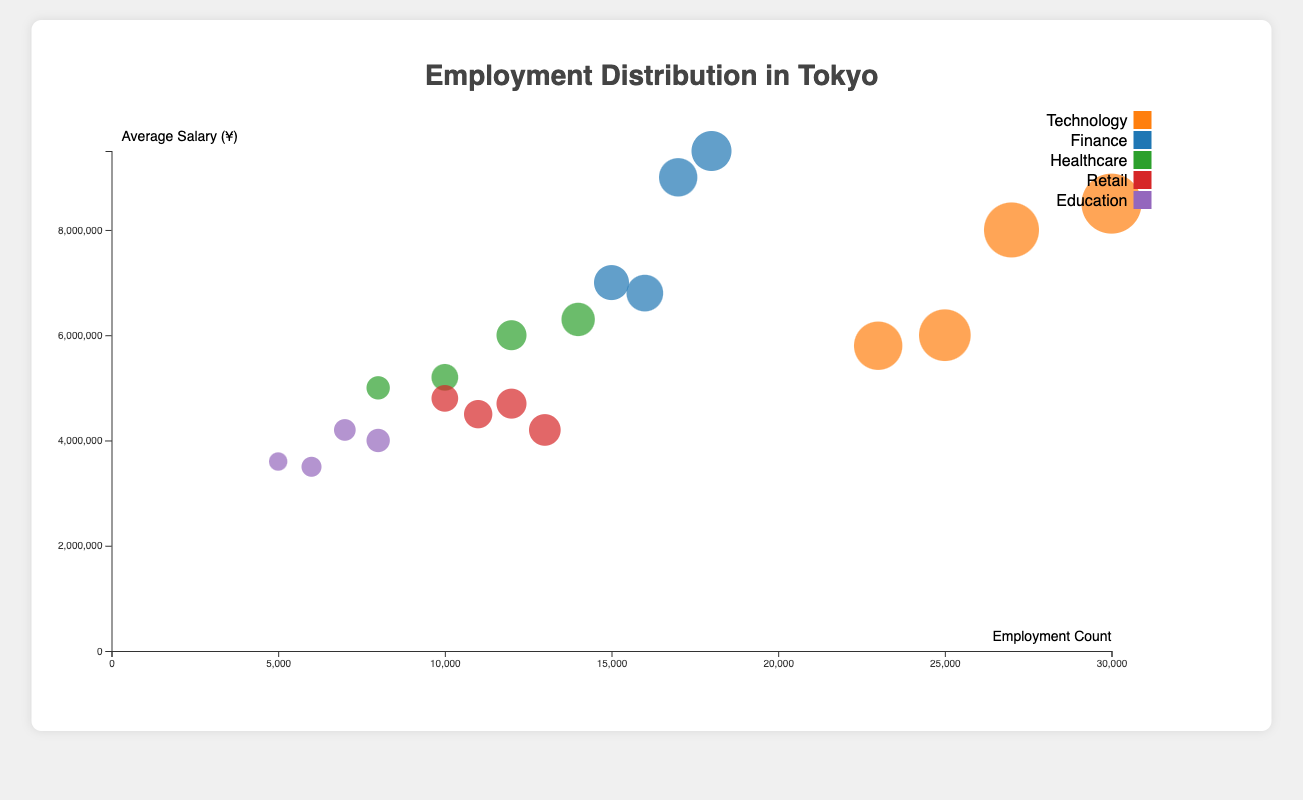What is the title of the plot? The title of the plot can be found at the top in the center. It reads "Employment Distribution in Tokyo".
Answer: Employment Distribution in Tokyo Which industry has the highest employment count among males aged 31-40? Find the circle representing males aged 31-40 in each industry. The Technology Industry has the largest bubble, indicating it has the highest employment count.
Answer: Technology What is the average salary of females aged 20-30 in the Finance industry? Locate the bubble for females aged 20-30 in the Finance industry. Look at the y-axis to determine the average salary, which is represented as ¥6,800,000.
Answer: ¥6,800,000 How many females are employed in Healthcare aged 20-30? Identify the bubble for females aged 20-30 in the Healthcare industry. The tooltip or bubble size indicates the employment count, which is 10,000.
Answer: 10,000 Compare the average salary of males aged 31-40 in Technology and Finance industries. Which one is higher, and by how much? Locate the respective bubbles for males aged 31-40 in both Technology and Finance industries. The average salary for Technology is ¥8,500,000 and for Finance is ¥9,500,000. The salary is higher in Finance by ¥1,000,000.
Answer: Finance, by ¥1,000,000 Which industry has the smallest employment count among females aged 20-30? Find the bubbles for females aged 20-30 in all industries and compare their sizes. The Education industry has the smallest bubble, indicating the smallest employment count of 6,000.
Answer: Education What is the difference in average salary between males and females aged 31-40 in the Healthcare industry? Locate the bubbles for males and females aged 31-40 in the Healthcare industry. The average salary for males is ¥6,000,000 and for females is ¥6,300,000. The difference is ¥300,000.
Answer: ¥300,000 In the plot, which industry shows a gender pay gap favoring females aged 31-40 more prominently? Look at the bubbles for males and females aged 31-40 in each industry and compare their y-axis positions. In Healthcare, females have a higher average salary by ¥300,000, marking the most notable gap favoring females.
Answer: Healthcare How does the employment count of males aged 20-30 in Technology compare to those in Retail? Compare the bubbles for males aged 20-30 in Technology and Retail industries. The count in Technology is 25,000, while in Retail it's 11,000. Technology has a higher count by 14,000.
Answer: Technology by 14,000 What is the total employment count of males aged 20-30 across all industries? Sum the employment counts of males aged 20-30 in each industry: (Technology: 25,000) + (Finance: 15,000) + (Healthcare: 8,000) + (Retail: 11,000) + (Education: 5,000) = 64,000.
Answer: 64,000 